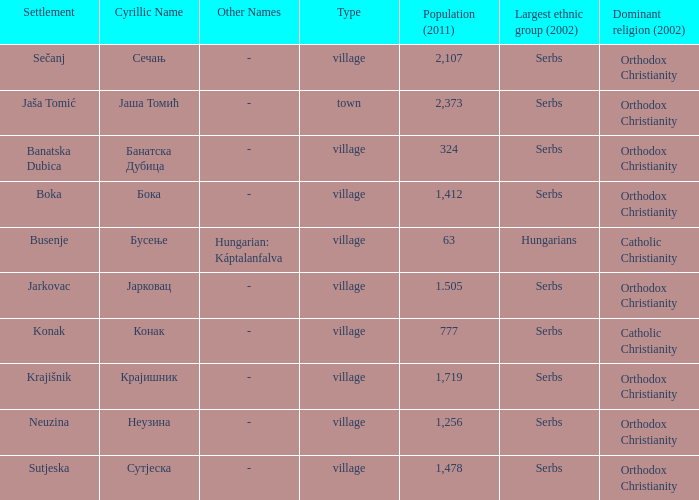What town has the population of 777? Конак. 